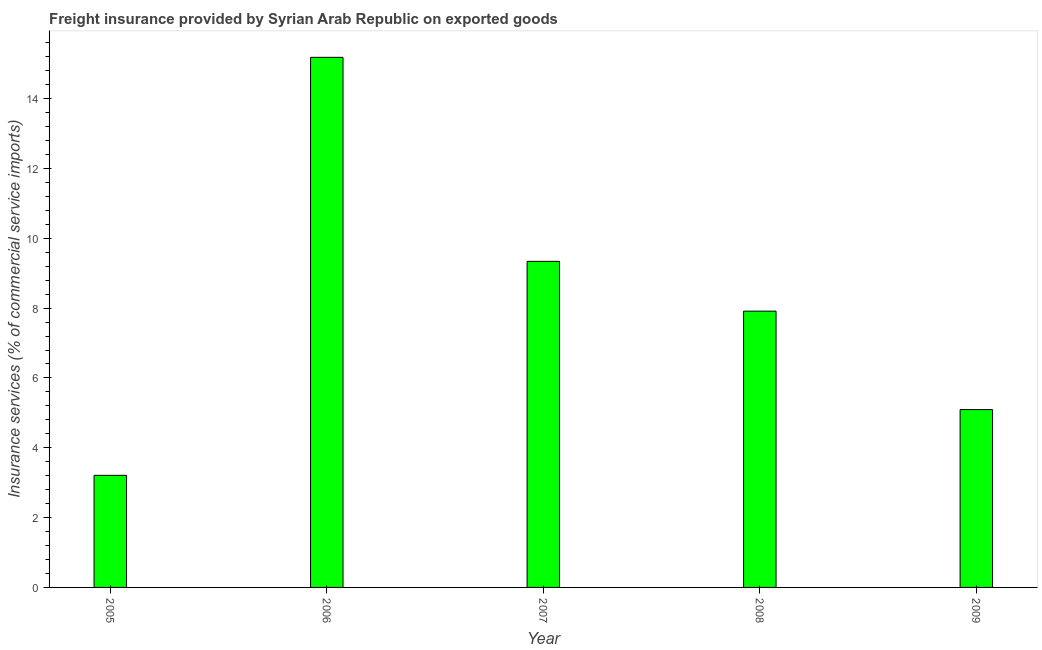Does the graph contain any zero values?
Ensure brevity in your answer.  No. Does the graph contain grids?
Offer a very short reply. No. What is the title of the graph?
Your answer should be compact. Freight insurance provided by Syrian Arab Republic on exported goods . What is the label or title of the X-axis?
Provide a succinct answer. Year. What is the label or title of the Y-axis?
Offer a very short reply. Insurance services (% of commercial service imports). What is the freight insurance in 2009?
Provide a short and direct response. 5.09. Across all years, what is the maximum freight insurance?
Provide a short and direct response. 15.18. Across all years, what is the minimum freight insurance?
Offer a terse response. 3.21. In which year was the freight insurance maximum?
Keep it short and to the point. 2006. In which year was the freight insurance minimum?
Make the answer very short. 2005. What is the sum of the freight insurance?
Make the answer very short. 40.74. What is the difference between the freight insurance in 2005 and 2007?
Your answer should be compact. -6.13. What is the average freight insurance per year?
Keep it short and to the point. 8.15. What is the median freight insurance?
Make the answer very short. 7.91. In how many years, is the freight insurance greater than 1.2 %?
Your answer should be compact. 5. What is the ratio of the freight insurance in 2006 to that in 2008?
Make the answer very short. 1.92. Is the freight insurance in 2005 less than that in 2008?
Your response must be concise. Yes. What is the difference between the highest and the second highest freight insurance?
Give a very brief answer. 5.84. Is the sum of the freight insurance in 2005 and 2007 greater than the maximum freight insurance across all years?
Offer a very short reply. No. What is the difference between the highest and the lowest freight insurance?
Your answer should be compact. 11.97. In how many years, is the freight insurance greater than the average freight insurance taken over all years?
Provide a succinct answer. 2. How many bars are there?
Offer a terse response. 5. What is the difference between two consecutive major ticks on the Y-axis?
Offer a terse response. 2. Are the values on the major ticks of Y-axis written in scientific E-notation?
Your answer should be compact. No. What is the Insurance services (% of commercial service imports) of 2005?
Provide a short and direct response. 3.21. What is the Insurance services (% of commercial service imports) of 2006?
Provide a succinct answer. 15.18. What is the Insurance services (% of commercial service imports) in 2007?
Keep it short and to the point. 9.34. What is the Insurance services (% of commercial service imports) of 2008?
Your answer should be compact. 7.91. What is the Insurance services (% of commercial service imports) of 2009?
Keep it short and to the point. 5.09. What is the difference between the Insurance services (% of commercial service imports) in 2005 and 2006?
Your answer should be very brief. -11.97. What is the difference between the Insurance services (% of commercial service imports) in 2005 and 2007?
Your answer should be compact. -6.13. What is the difference between the Insurance services (% of commercial service imports) in 2005 and 2008?
Your response must be concise. -4.7. What is the difference between the Insurance services (% of commercial service imports) in 2005 and 2009?
Make the answer very short. -1.88. What is the difference between the Insurance services (% of commercial service imports) in 2006 and 2007?
Your response must be concise. 5.84. What is the difference between the Insurance services (% of commercial service imports) in 2006 and 2008?
Offer a very short reply. 7.27. What is the difference between the Insurance services (% of commercial service imports) in 2006 and 2009?
Provide a succinct answer. 10.09. What is the difference between the Insurance services (% of commercial service imports) in 2007 and 2008?
Give a very brief answer. 1.43. What is the difference between the Insurance services (% of commercial service imports) in 2007 and 2009?
Provide a succinct answer. 4.25. What is the difference between the Insurance services (% of commercial service imports) in 2008 and 2009?
Provide a short and direct response. 2.82. What is the ratio of the Insurance services (% of commercial service imports) in 2005 to that in 2006?
Your answer should be compact. 0.21. What is the ratio of the Insurance services (% of commercial service imports) in 2005 to that in 2007?
Offer a very short reply. 0.34. What is the ratio of the Insurance services (% of commercial service imports) in 2005 to that in 2008?
Offer a terse response. 0.41. What is the ratio of the Insurance services (% of commercial service imports) in 2005 to that in 2009?
Provide a succinct answer. 0.63. What is the ratio of the Insurance services (% of commercial service imports) in 2006 to that in 2007?
Ensure brevity in your answer.  1.63. What is the ratio of the Insurance services (% of commercial service imports) in 2006 to that in 2008?
Offer a terse response. 1.92. What is the ratio of the Insurance services (% of commercial service imports) in 2006 to that in 2009?
Ensure brevity in your answer.  2.98. What is the ratio of the Insurance services (% of commercial service imports) in 2007 to that in 2008?
Provide a short and direct response. 1.18. What is the ratio of the Insurance services (% of commercial service imports) in 2007 to that in 2009?
Offer a terse response. 1.83. What is the ratio of the Insurance services (% of commercial service imports) in 2008 to that in 2009?
Make the answer very short. 1.55. 